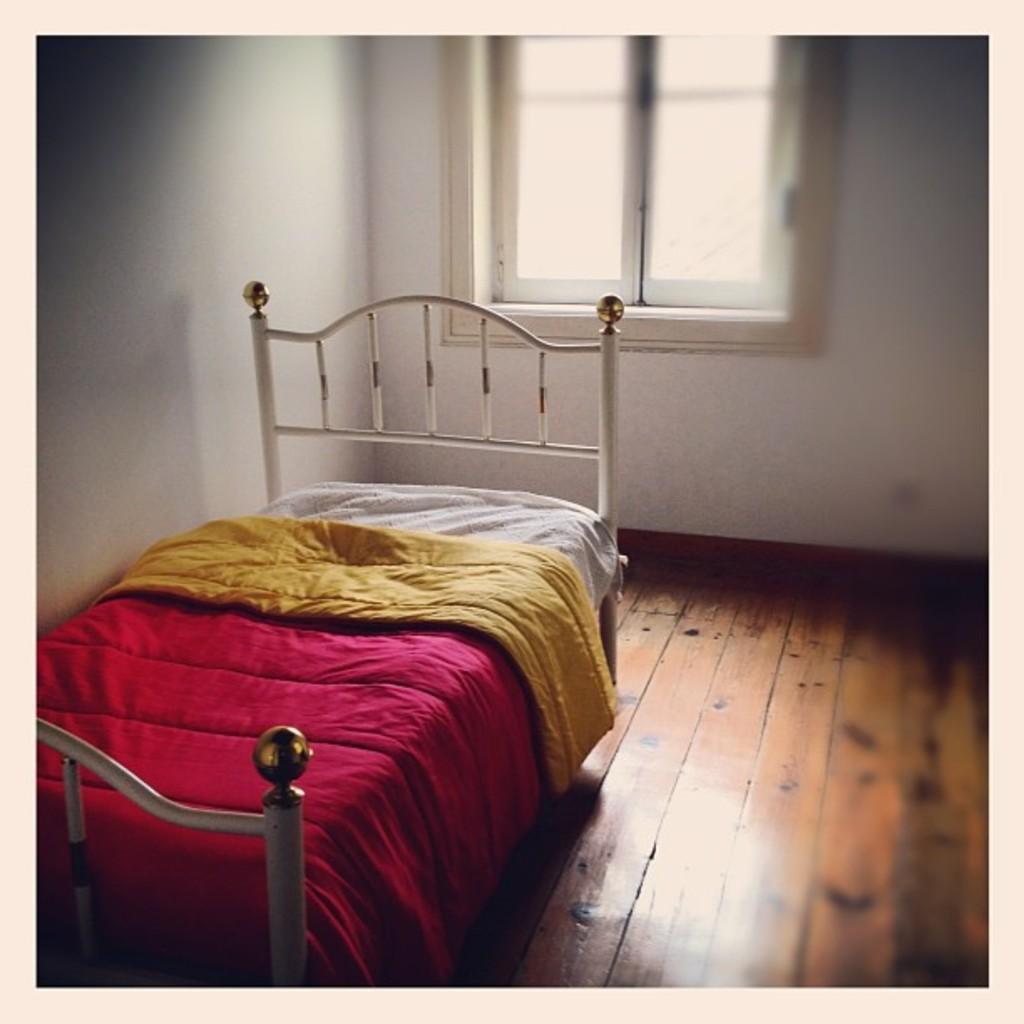How would you summarize this image in a sentence or two? This is an edited picture. I can see a bed with blankets, and in the background there are walls and a window. 